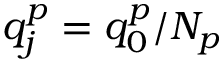<formula> <loc_0><loc_0><loc_500><loc_500>q _ { j } ^ { p } = q _ { 0 } ^ { p } / N _ { p }</formula> 